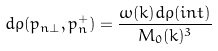<formula> <loc_0><loc_0><loc_500><loc_500>d \rho ( { p } _ { n \bot } , p _ { n } ^ { + } ) = \frac { \omega ( { k } ) d \rho ( i n t ) } { M _ { 0 } ( { k } ) ^ { 3 } }</formula> 